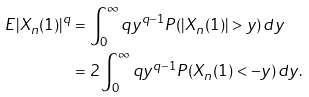Convert formula to latex. <formula><loc_0><loc_0><loc_500><loc_500>E | X _ { n } ( 1 ) | ^ { q } & = \int _ { 0 } ^ { \infty } { q y ^ { q - 1 } P ( | X _ { n } ( 1 ) | > y ) \, d y } \\ & = 2 \int _ { 0 } ^ { \infty } { q y ^ { q - 1 } P ( X _ { n } ( 1 ) < - y ) \, d y } .</formula> 